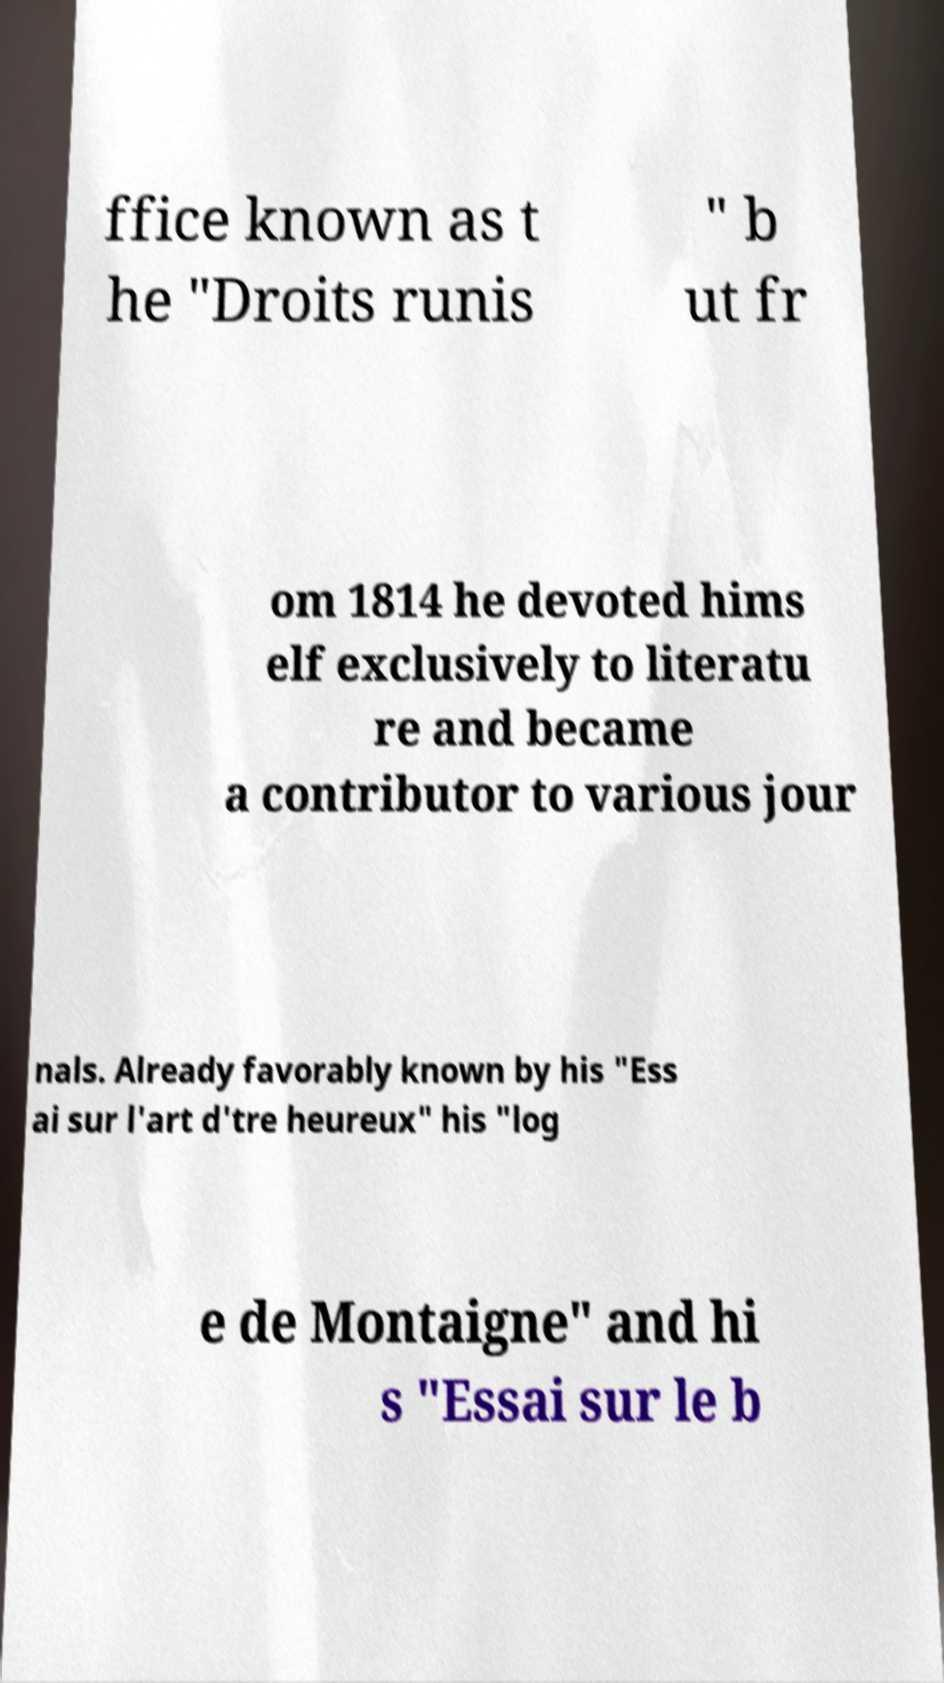Could you assist in decoding the text presented in this image and type it out clearly? ffice known as t he "Droits runis " b ut fr om 1814 he devoted hims elf exclusively to literatu re and became a contributor to various jour nals. Already favorably known by his "Ess ai sur l'art d'tre heureux" his "log e de Montaigne" and hi s "Essai sur le b 